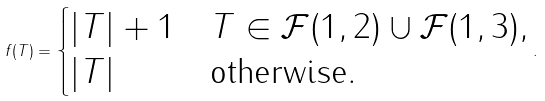<formula> <loc_0><loc_0><loc_500><loc_500>f ( T ) = \begin{cases} \left | T \right | + 1 & T \in \mathcal { F } ( 1 , 2 ) \cup \mathcal { F } ( 1 , 3 ) , \\ \left | T \right | & \text {otherwise} . \end{cases} .</formula> 